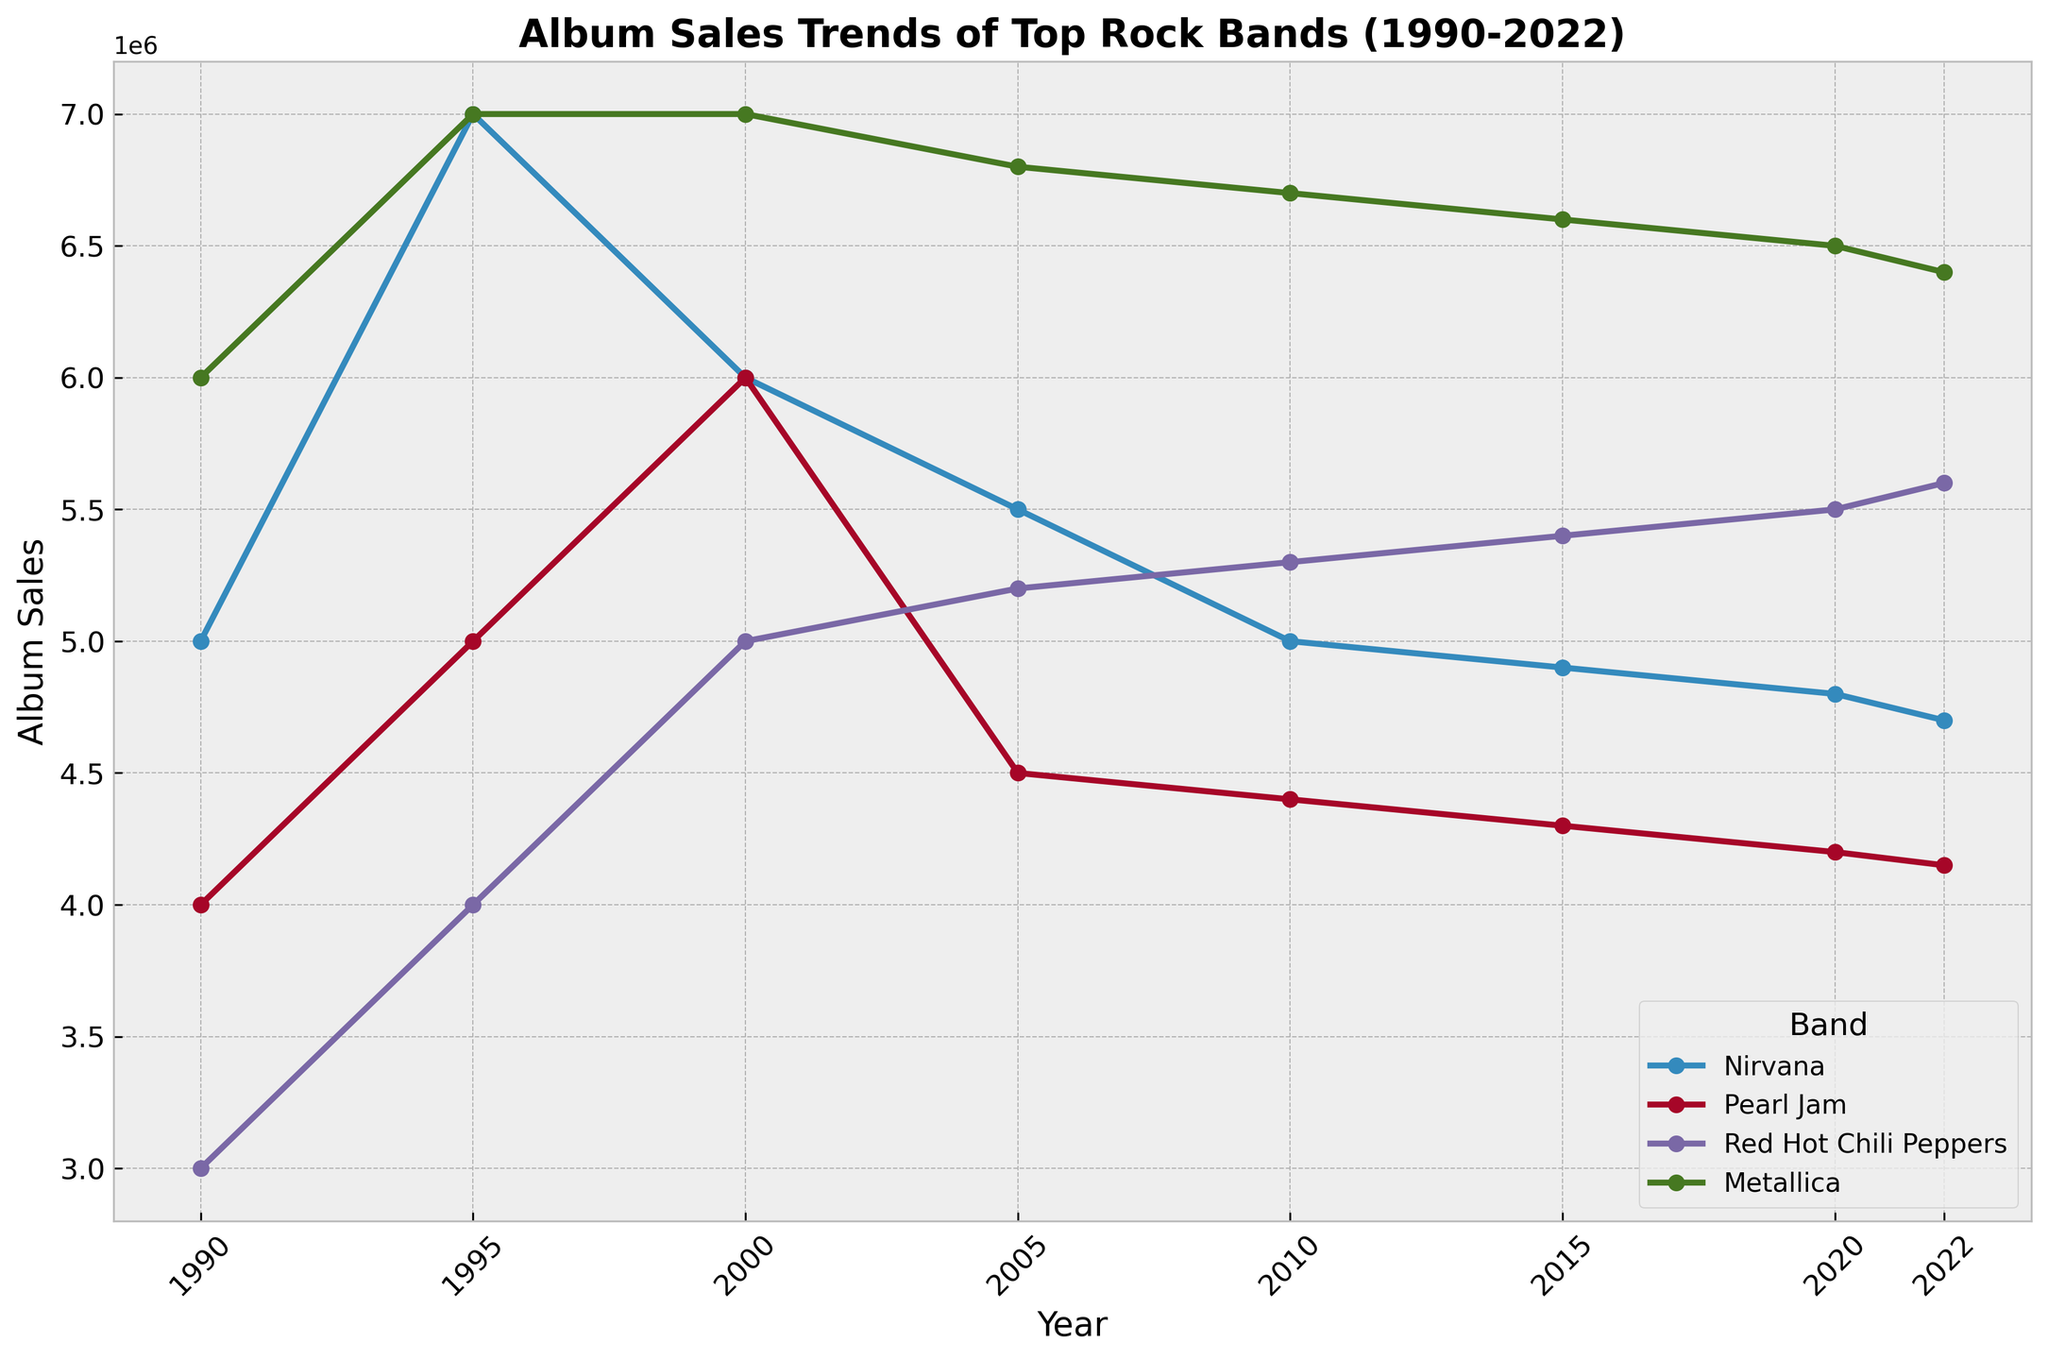What has been the general trend of Metallica's album sales from 1990 to 2022? Metallica's album sales peaked in 1995 and 2000 at 7 million, then declined slightly over the years, showing a very gradual decrease from 2005 to 2022.
Answer: Gradual decrease Which band had the highest album sales in 1990, and what were those sales? In 1990, Metallica had the highest album sales, totaling 6 million.
Answer: Metallica, 6 million In which year did Pearl Jam achieve their highest album sales according to the figure? Pearl Jam reached their highest album sales in the year 2000, with sales of 6 million.
Answer: 2000 How do the album sales of Nirvana in 2015 compare to their sales in 2005? Nirvana's album sales in 2015 were 4.9 million compared to 5.5 million in 2005, showing a decrease of 0.6 million.
Answer: Decreased by 0.6 million Which band had increasing album sales from 2010 to 2022, and how much did those sales increase? The Red Hot Chili Peppers had increasing album sales from 2010 (5.3 million) to 2022 (5.6 million), an increase of 0.3 million.
Answer: Red Hot Chili Peppers, increased by 0.3 million Between 2005 and 2015, which band showed the most consistent trend in album sales? Metallica showed the most consistent trend in album sales between 2005 and 2015, with sales decreasing gradually but steadily from 6.8 million to 6.6 million, only a difference of 0.2 million.
Answer: Metallica In the year 2022, which band had the lowest album sales, and what were they? In 2022, Pearl Jam had the lowest album sales at 4.15 million.
Answer: Pearl Jam, 4.15 million Compare the album sales of Nirvana and Red Hot Chili Peppers in 2005. Which band had higher sales and by how much? In 2005, Nirvana had sales of 5.5 million while Red Hot Chili Peppers had sales of 5.2 million. Nirvana had higher sales by 0.3 million.
Answer: Nirvana, by 0.3 million What's the average album sales of Pearl Jam across all the years? To find the average, sum all of Pearl Jam's sales from each year and divide by the number of years. (4000000 + 5000000 + 6000000 + 4500000 + 4400000 + 4300000 + 4200000 + 4150000) / 8 = 44,050,000 / 8 = 5,506,250.
Answer: 5,506,250 Which year had the highest overall album sales for all bands combined, and what was the total sales figure? Sum the sales for all bands for each year and identify the year with the highest total. 1995 has the highest combined sales: (7,000,000 + 5,000,000 + 4,000,000 + 7,000,000) = 23,000,000.
Answer: 1995, 23 million 